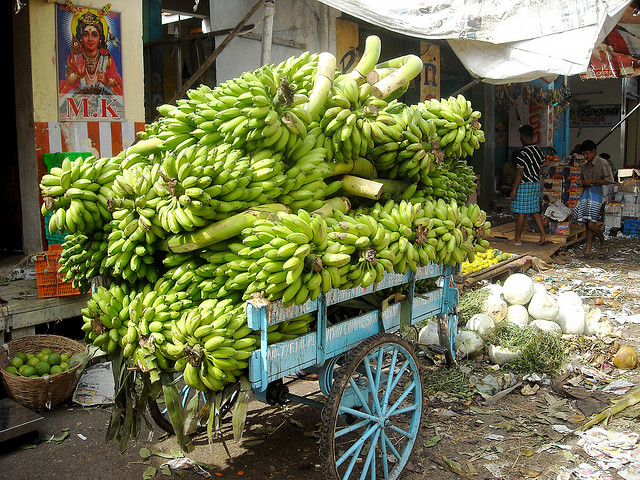Please transcribe the text information in this image. K M P R 